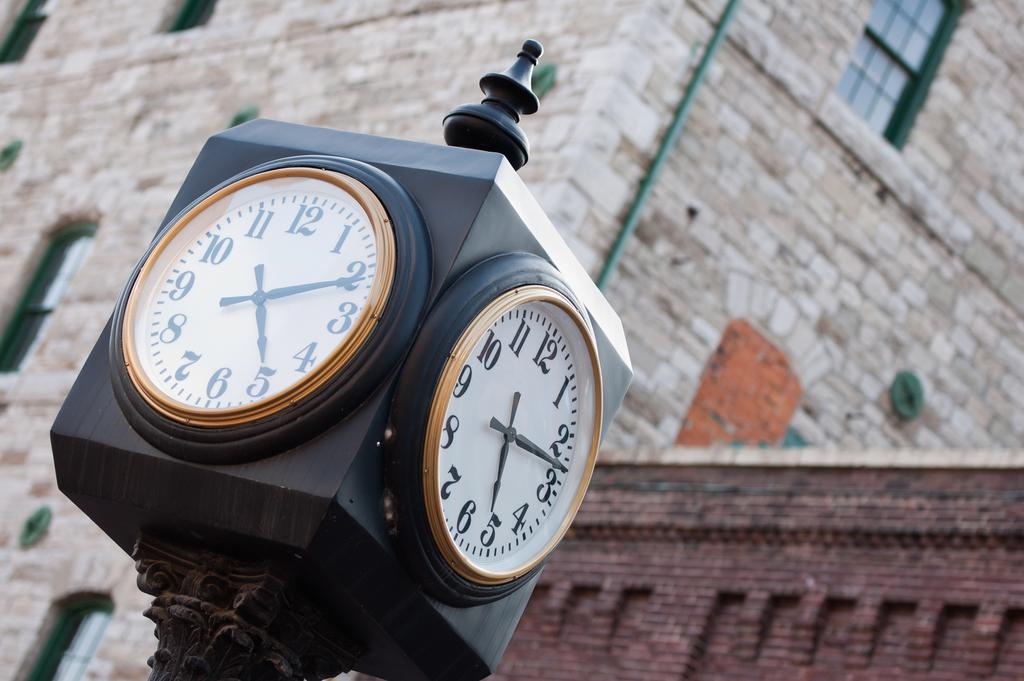<image>
Provide a brief description of the given image. A square clock on a pole is outside a brick building and shows the time 5:11. 